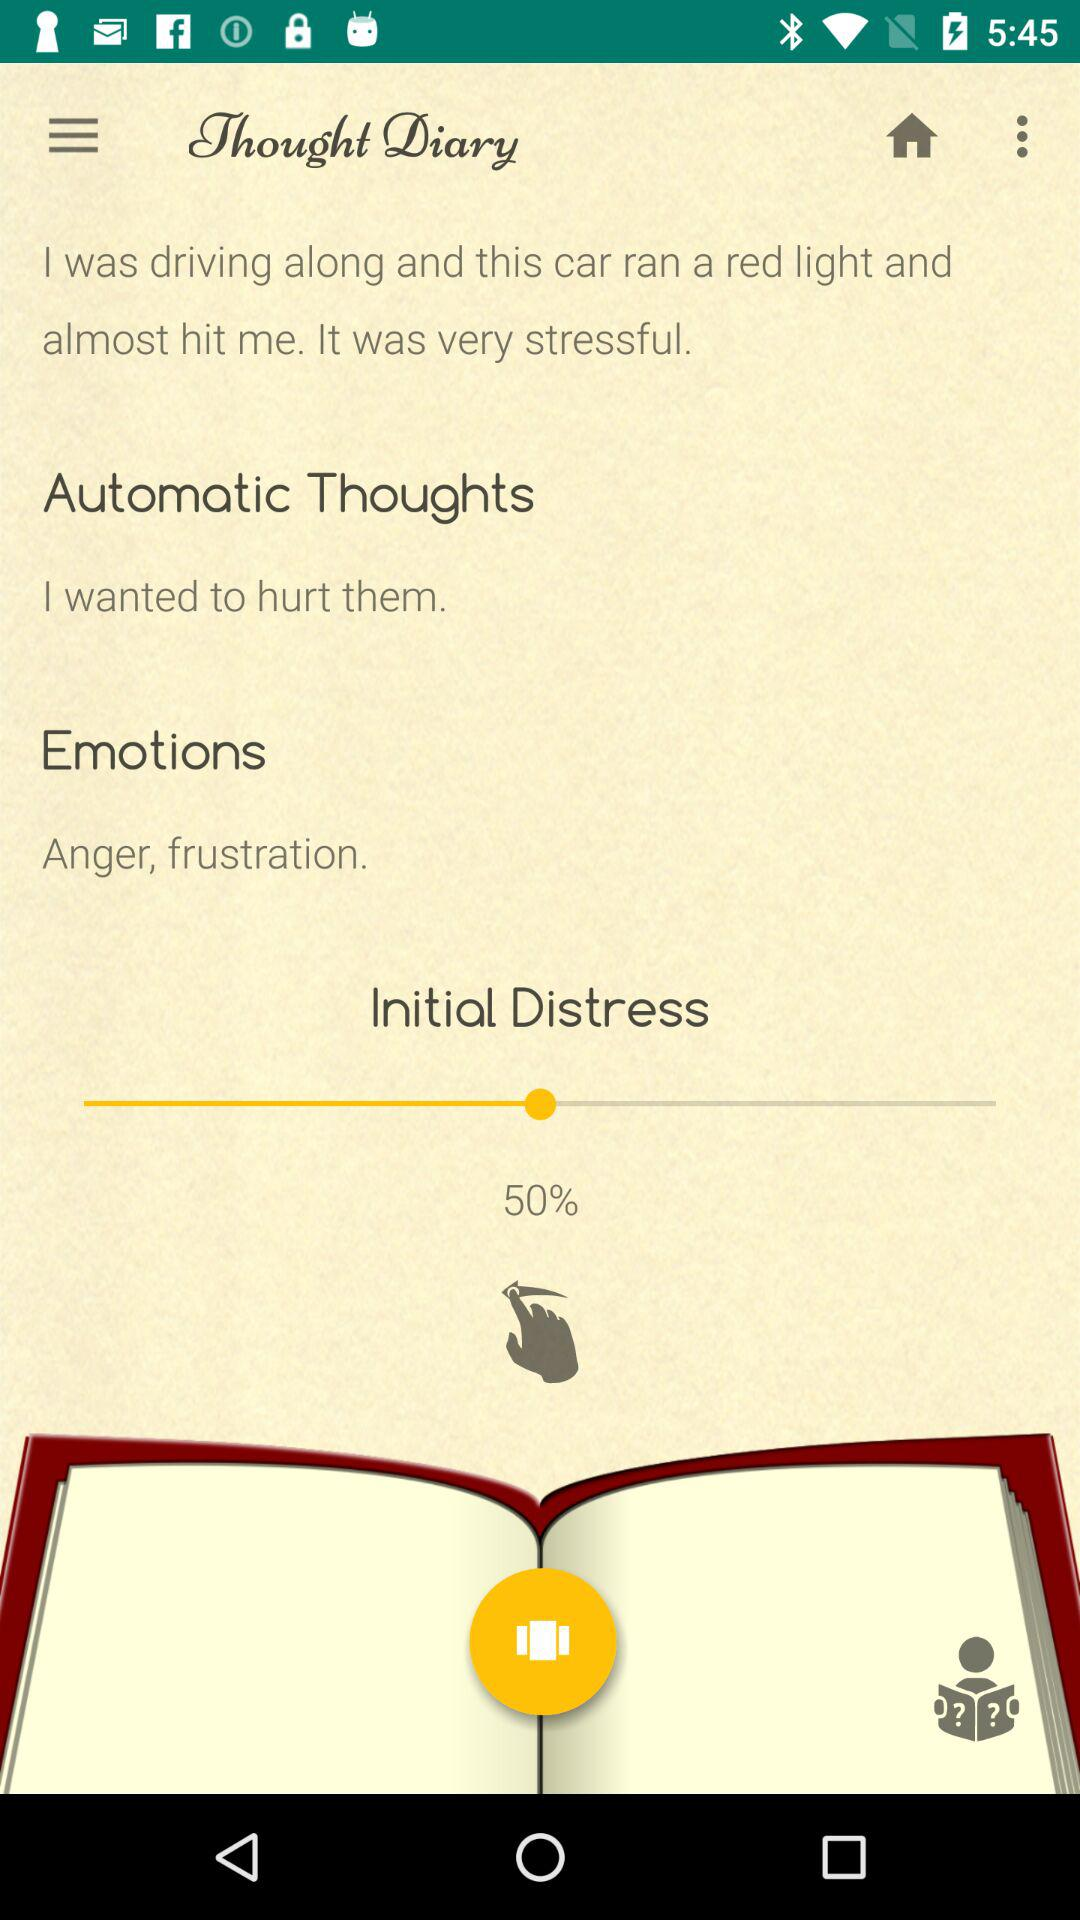What is the selected percentage of "Initial Distress"? The selected percentage of "Initial Distress" is 50%. 